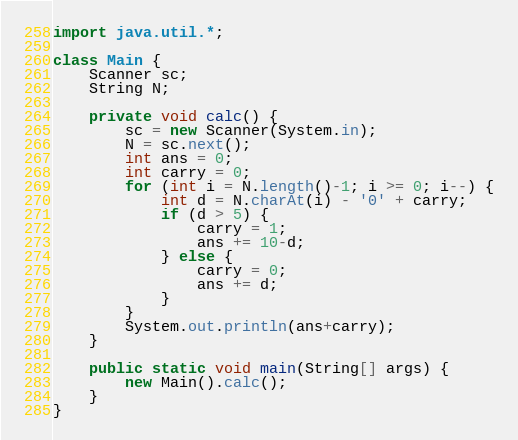<code> <loc_0><loc_0><loc_500><loc_500><_Java_>import java.util.*;

class Main {
	Scanner sc;
	String N;
	
	private void calc() {
		sc = new Scanner(System.in);
		N = sc.next();
		int ans = 0;
		int carry = 0;
		for (int i = N.length()-1; i >= 0; i--) {
			int d = N.charAt(i) - '0' + carry;
			if (d > 5) {
				carry = 1;
				ans += 10-d;
			} else {
				carry = 0;
				ans += d;
			}
		}
		System.out.println(ans+carry);
	}
	
	public static void main(String[] args) {
		new Main().calc();
	}
}
</code> 